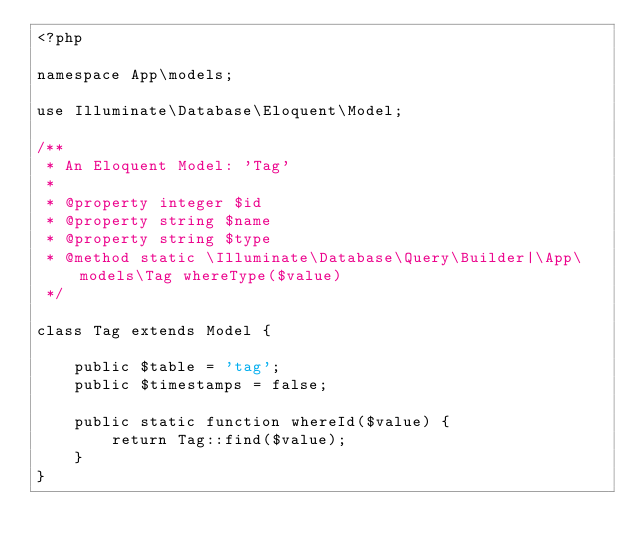<code> <loc_0><loc_0><loc_500><loc_500><_PHP_><?php

namespace App\models;

use Illuminate\Database\Eloquent\Model;

/**
 * An Eloquent Model: 'Tag'
 *
 * @property integer $id
 * @property string $name
 * @property string $type
 * @method static \Illuminate\Database\Query\Builder|\App\models\Tag whereType($value)
 */

class Tag extends Model {

    public $table = 'tag';
    public $timestamps = false;

    public static function whereId($value) {
        return Tag::find($value);
    }
}
</code> 